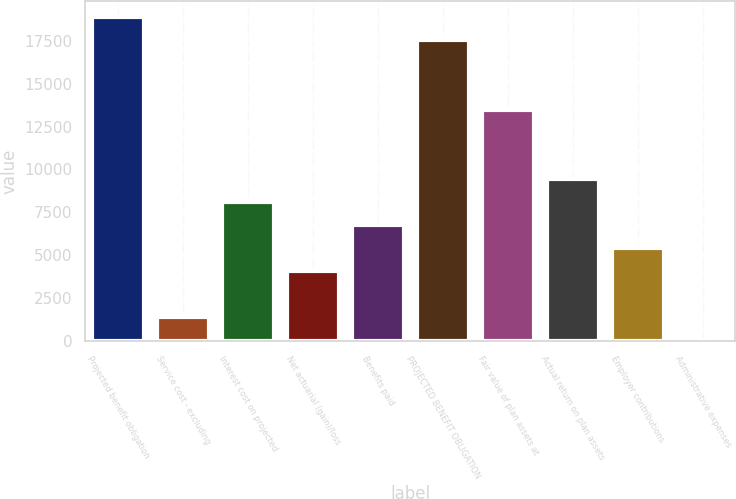Convert chart to OTSL. <chart><loc_0><loc_0><loc_500><loc_500><bar_chart><fcel>Projected benefit obligation<fcel>Service cost - excluding<fcel>Interest cost on projected<fcel>Net actuarial (gain)/loss<fcel>Benefits paid<fcel>PROJECTED BENEFIT OBLIGATION<fcel>Fair value of plan assets at<fcel>Actual return on plan assets<fcel>Employer contributions<fcel>Administrative expenses<nl><fcel>18862.4<fcel>1376.1<fcel>8101.6<fcel>4066.3<fcel>6756.5<fcel>17517.3<fcel>13482<fcel>9446.7<fcel>5411.4<fcel>31<nl></chart> 